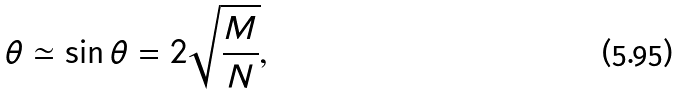Convert formula to latex. <formula><loc_0><loc_0><loc_500><loc_500>\theta \simeq \sin \theta = 2 \sqrt { \frac { M } { N } } ,</formula> 